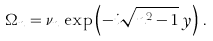Convert formula to latex. <formula><loc_0><loc_0><loc_500><loc_500>\Omega _ { n } = \nu _ { n } \, \exp \left ( - i \sqrt { n ^ { 2 } - 1 } \, y \right ) \, .</formula> 